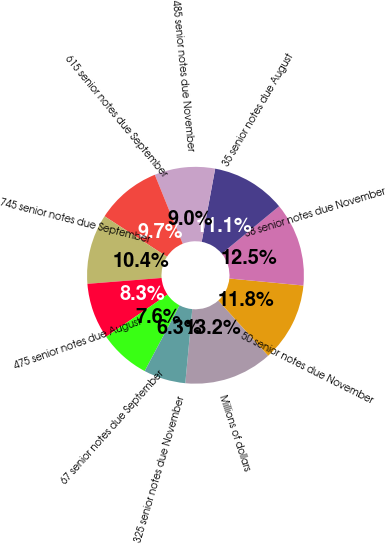Convert chart to OTSL. <chart><loc_0><loc_0><loc_500><loc_500><pie_chart><fcel>Millions of dollars<fcel>50 senior notes due November<fcel>38 senior notes due November<fcel>35 senior notes due August<fcel>485 senior notes due November<fcel>615 senior notes due September<fcel>745 senior notes due September<fcel>475 senior notes due August<fcel>67 senior notes due September<fcel>325 senior notes due November<nl><fcel>13.19%<fcel>11.8%<fcel>12.49%<fcel>11.11%<fcel>9.03%<fcel>9.72%<fcel>10.42%<fcel>8.34%<fcel>7.64%<fcel>6.26%<nl></chart> 